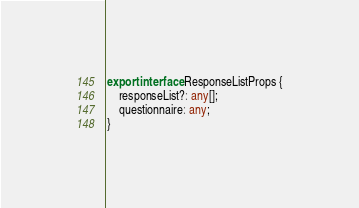<code> <loc_0><loc_0><loc_500><loc_500><_TypeScript_>export interface ResponseListProps {
    responseList?: any[];
    questionnaire: any;
}</code> 